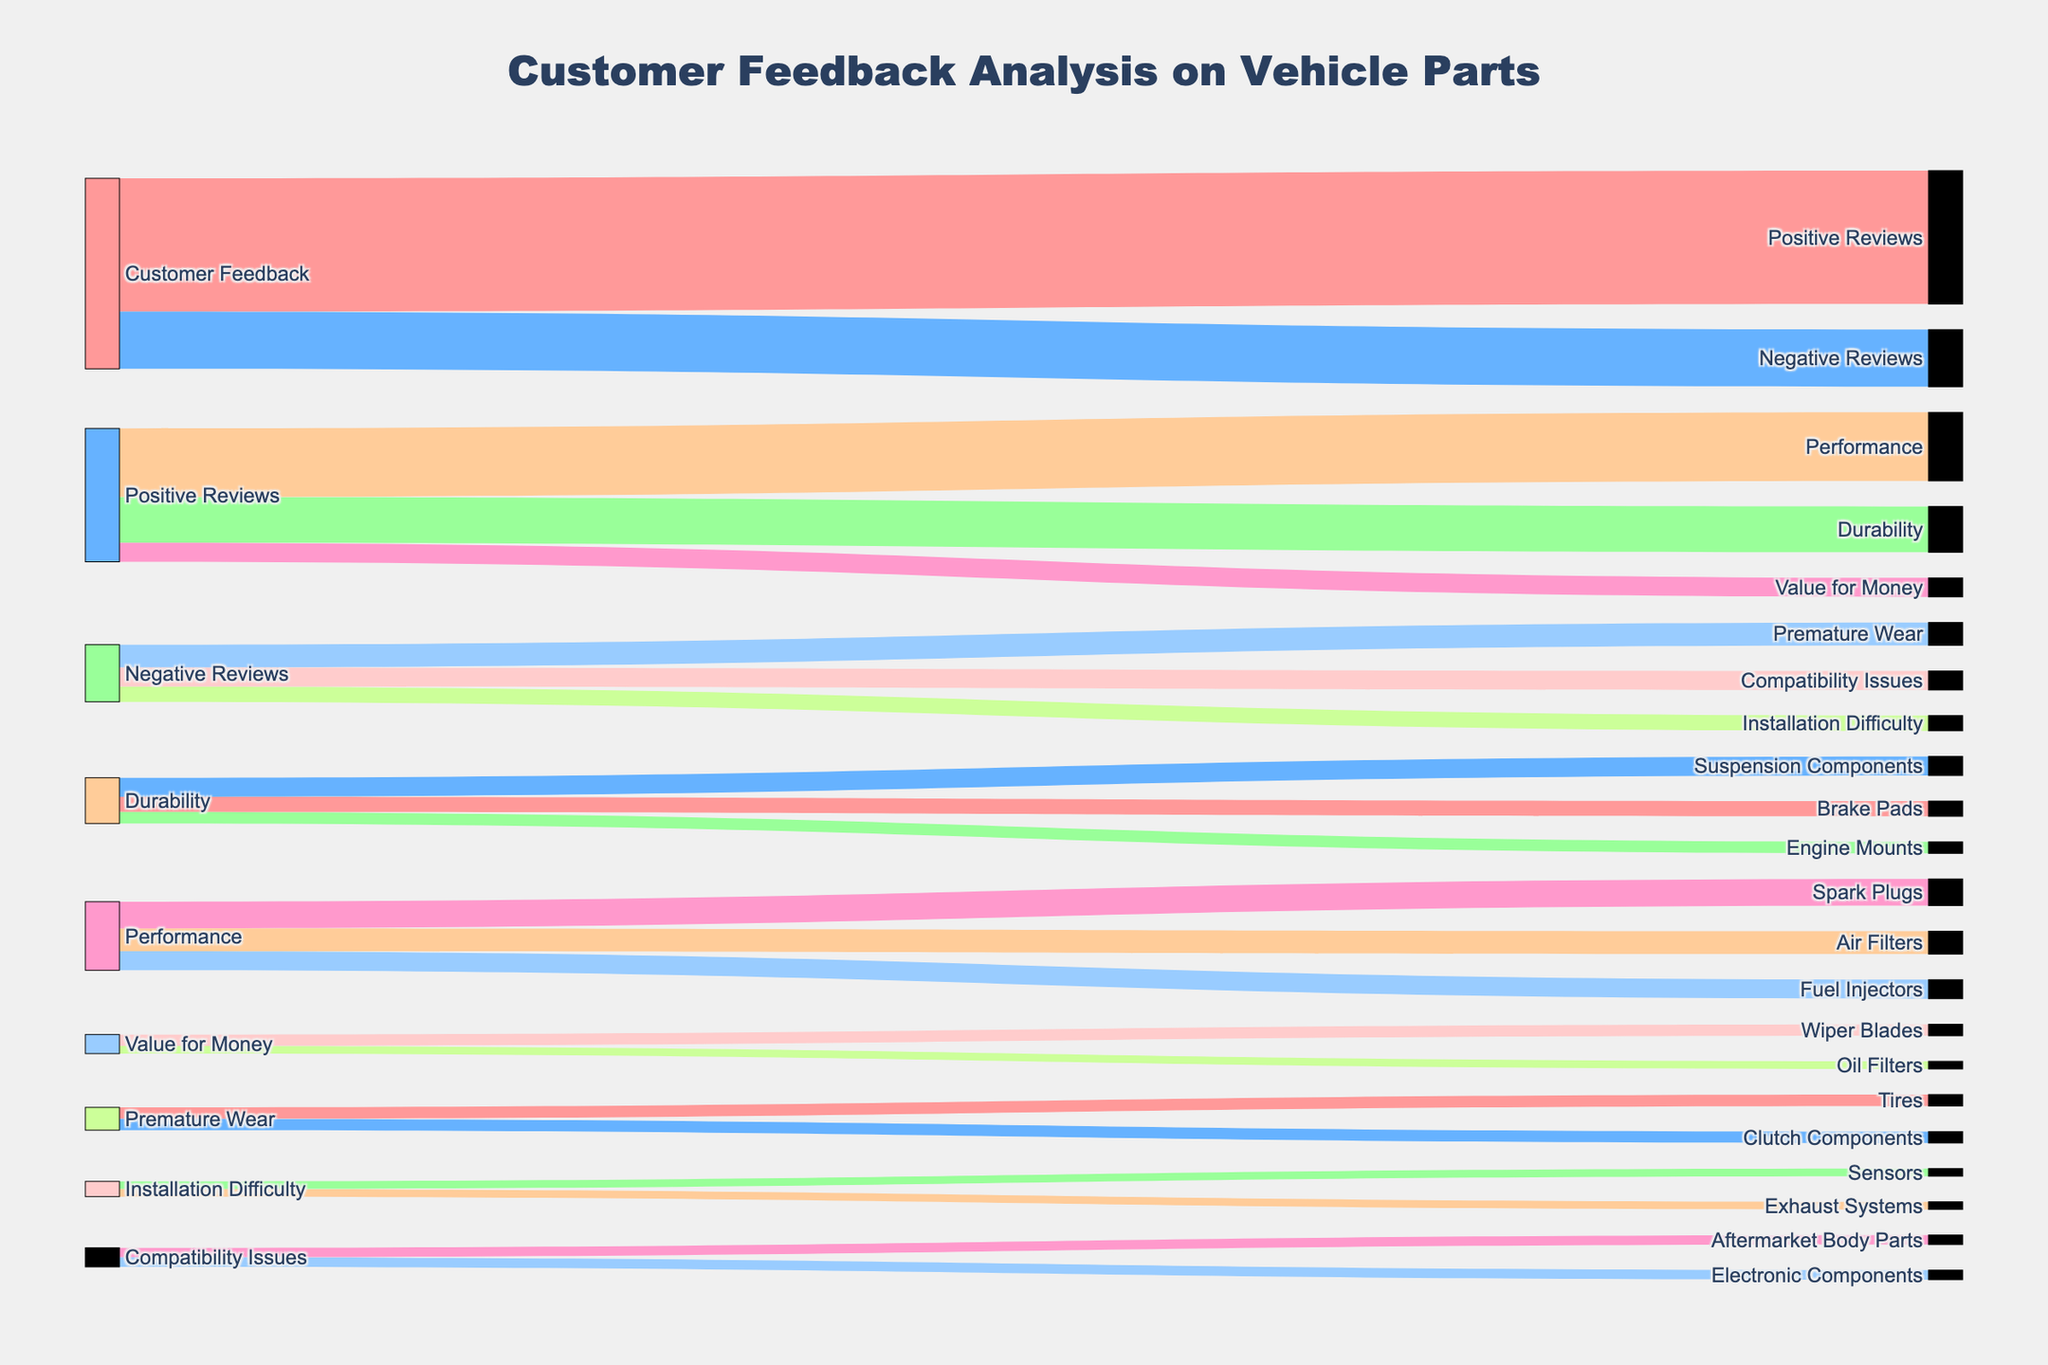What is the title of the diagram? The title of the diagram is displayed at the top of the Sankey Diagram, which provides the overarching theme of the data presented.
Answer: Customer Feedback Analysis on Vehicle Parts How many categories are there under Positive Reviews? To find the number of categories under Positive Reviews, locate the "Positive Reviews" node and count the outward links connected to it.
Answer: 3 Which part experienced the most Premature Wear complaints? Look under the Negative Reviews category for Premature Wear and identify the part with the highest value.
Answer: Tires and Clutch Components What is the total number of reviews analyzed in the diagram? Add up all the values from the "Customer Feedback" node, which represents the total number of reviews, both positive and negative.
Answer: 5000 How many reviews focused on Durability? Find the sum of the values leading to Durability under Positive Reviews.
Answer: 1200 Which category received more positive reviews: Durability or Performance? Compare the values under Positive Reviews for Durability and Performance.
Answer: Performance What is the difference in the number of reviews mentioning Durability and Value for Money? Subtract the number of reviews for Value for Money from the number of reviews for Durability.
Answer: 700 How do the counts for Spark Plugs and Fuel Injectors compare? Check the values allocated to Performance under Positive Reviews for Spark Plugs and Fuel Injectors.
Answer: Spark Plugs have more What is the combined total number of negative reviews for Compatibility Issues and Installation Difficulty? Add the values for Compatibility Issues and Installation Difficulty under Negative Reviews.
Answer: 900 Which vehicle part received the least positive feedback for Value for Money? Under Value for Money, check which of the parts (Oil Filters or Wiper Blades) has a smaller value.
Answer: Oil Filters 